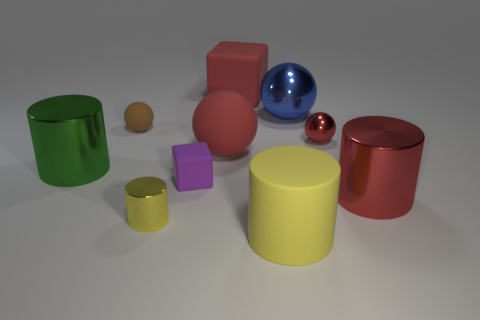How many other things are there of the same color as the big block? Upon reviewing the visual composition, it seems there are four prominent objects with varying shades of red: one large block, one cylinder, and two smaller spheres. However, if precision in hue is crucial, and we only consider objects with a closely matching shade to that of the large red block, there appears to be just one - the cylinder. 